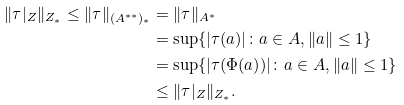<formula> <loc_0><loc_0><loc_500><loc_500>\| \tau | _ { Z } \| _ { Z _ { * } } \leq \| \tau \| _ { ( A ^ { * * } ) _ { * } } & = \| \tau \| _ { A ^ { * } } \\ & = \sup \{ | \tau ( a ) | \colon a \in A , \| a \| \leq 1 \} \\ & = \sup \{ | \tau ( \Phi ( a ) ) | \colon a \in A , \| a \| \leq 1 \} \\ & \leq \| \tau | _ { Z } \| _ { Z _ { * } } .</formula> 